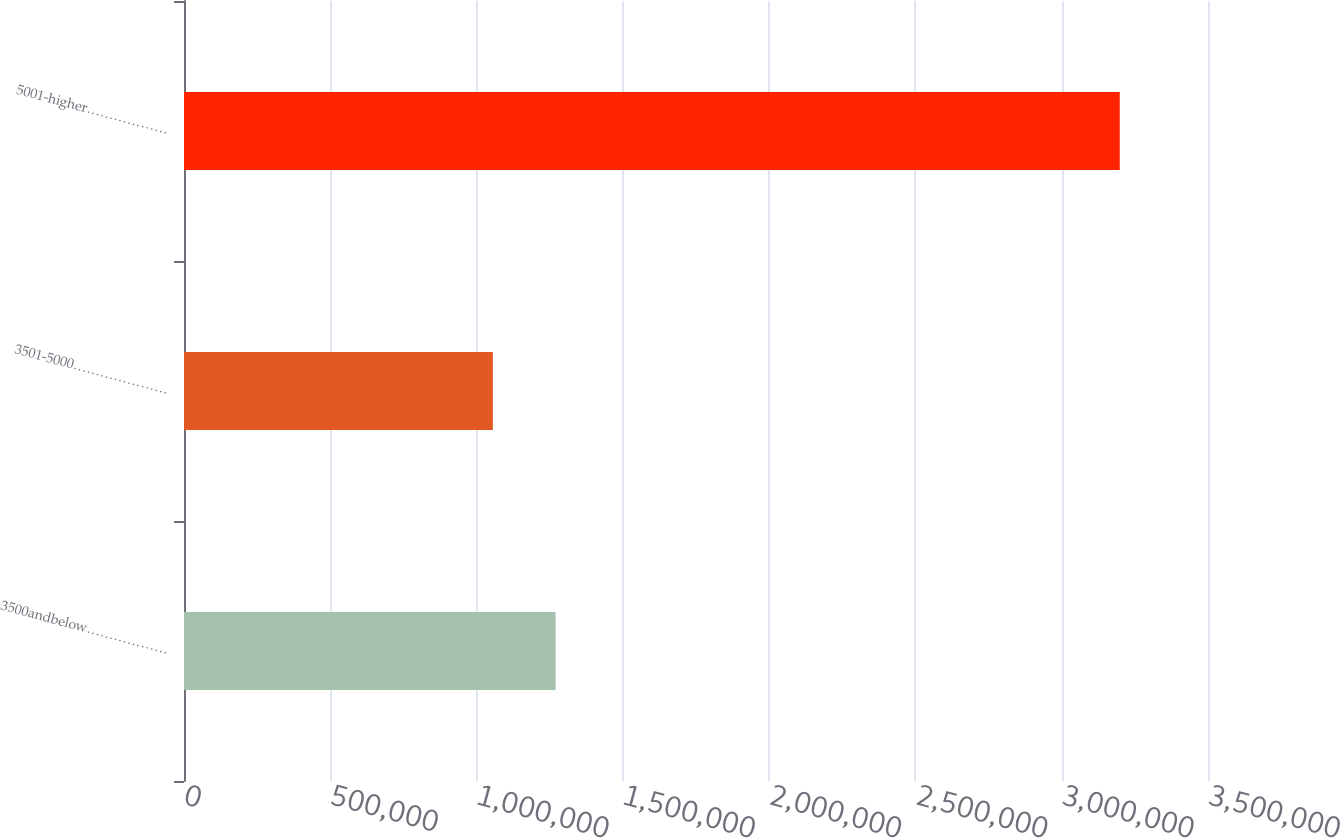Convert chart. <chart><loc_0><loc_0><loc_500><loc_500><bar_chart><fcel>3500andbelow………………<fcel>3501-5000…………………<fcel>5001-higher………………<nl><fcel>1.26999e+06<fcel>1.05572e+06<fcel>3.19846e+06<nl></chart> 